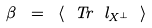Convert formula to latex. <formula><loc_0><loc_0><loc_500><loc_500>\beta \ = \ \langle \ T r \ l _ { X ^ { \bot } } \ \rangle</formula> 